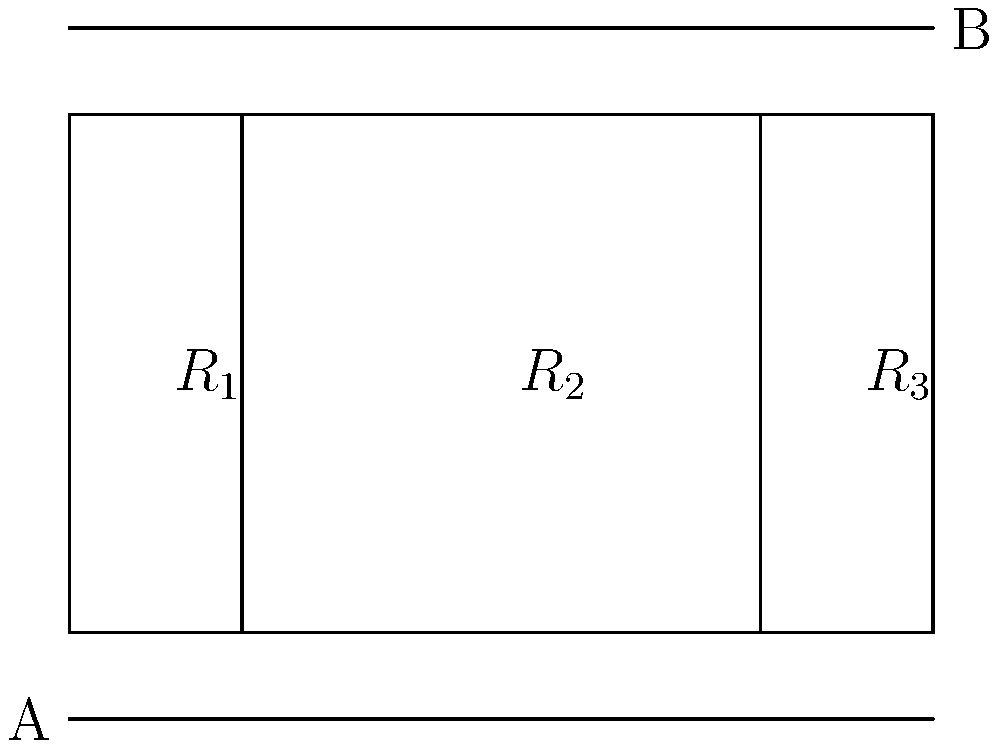In honor of Phil Niekro's knuckleball, let's throw a curveball in electrical engineering. Consider a circuit with three resistors connected as shown in the diagram. If $R_1 = 6\Omega$, $R_2 = 12\Omega$, and $R_3 = 4\Omega$, what is the total resistance between points A and B? Let's approach this step-by-step, just like we'd analyze a pitcher's technique:

1) First, we need to identify the circuit configuration. We can see that $R_2$ and $R_3$ are in parallel with each other, and this parallel combination is in series with $R_1$.

2) Let's start by calculating the equivalent resistance of the parallel combination of $R_2$ and $R_3$. The formula for resistors in parallel is:

   $\frac{1}{R_{eq}} = \frac{1}{R_2} + \frac{1}{R_3}$

3) Plugging in the values:

   $\frac{1}{R_{eq}} = \frac{1}{12} + \frac{1}{4} = \frac{1}{3} + \frac{1}{4} = \frac{4}{12} + \frac{3}{12} = \frac{7}{12}$

4) Taking the reciprocal:

   $R_{eq} = \frac{12}{7} \approx 1.71\Omega$

5) Now we have this equivalent resistance in series with $R_1$. For resistors in series, we simply add their values:

   $R_{total} = R_1 + R_{eq} = 6\Omega + \frac{12}{7}\Omega = \frac{42}{7}\Omega + \frac{12}{7}\Omega = \frac{54}{7}\Omega$

6) Simplifying:

   $R_{total} = \frac{54}{7}\Omega \approx 7.71\Omega$

Just like mastering the knuckleball, it's all about breaking down the problem and tackling it step by step!
Answer: $\frac{54}{7}\Omega$ or approximately $7.71\Omega$ 